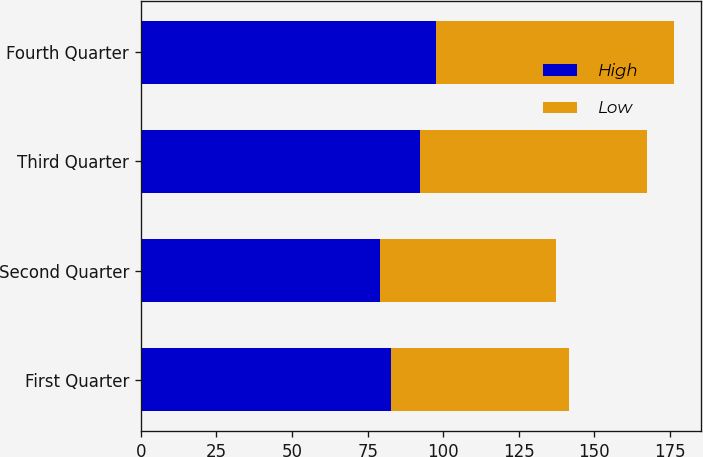Convert chart to OTSL. <chart><loc_0><loc_0><loc_500><loc_500><stacked_bar_chart><ecel><fcel>First Quarter<fcel>Second Quarter<fcel>Third Quarter<fcel>Fourth Quarter<nl><fcel>High<fcel>82.68<fcel>79.04<fcel>92.45<fcel>97.65<nl><fcel>Low<fcel>58.78<fcel>58.27<fcel>74.93<fcel>78.67<nl></chart> 